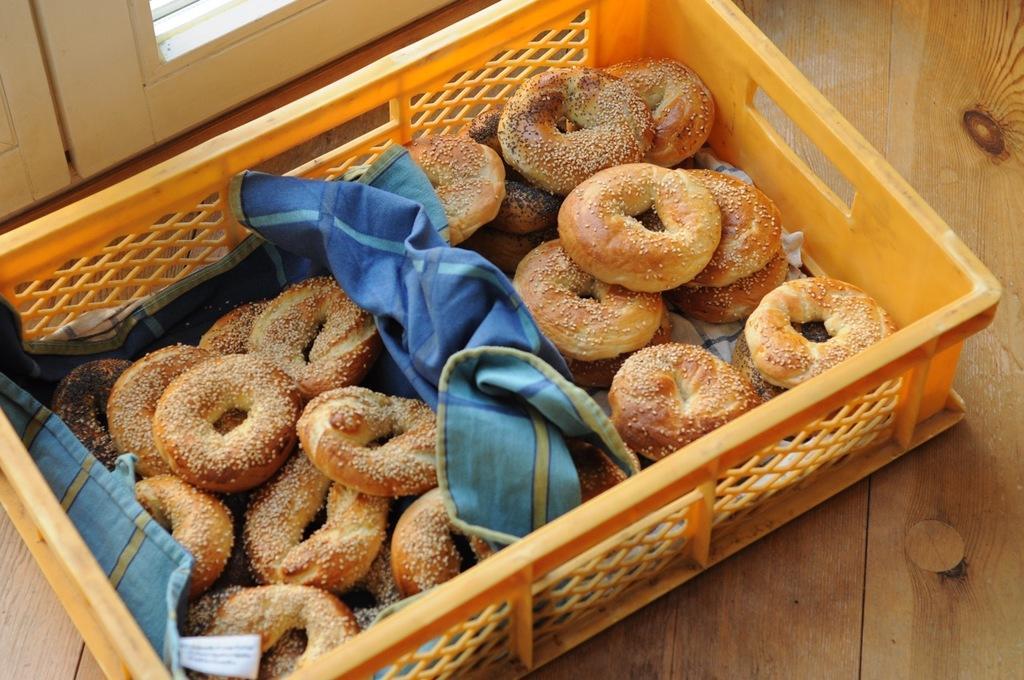In one or two sentences, can you explain what this image depicts? This picture is taken inside the room. In this image, we can see a basket, in the basket, we can see a cloth and some food item. In the background, we can see a door which is closed. 